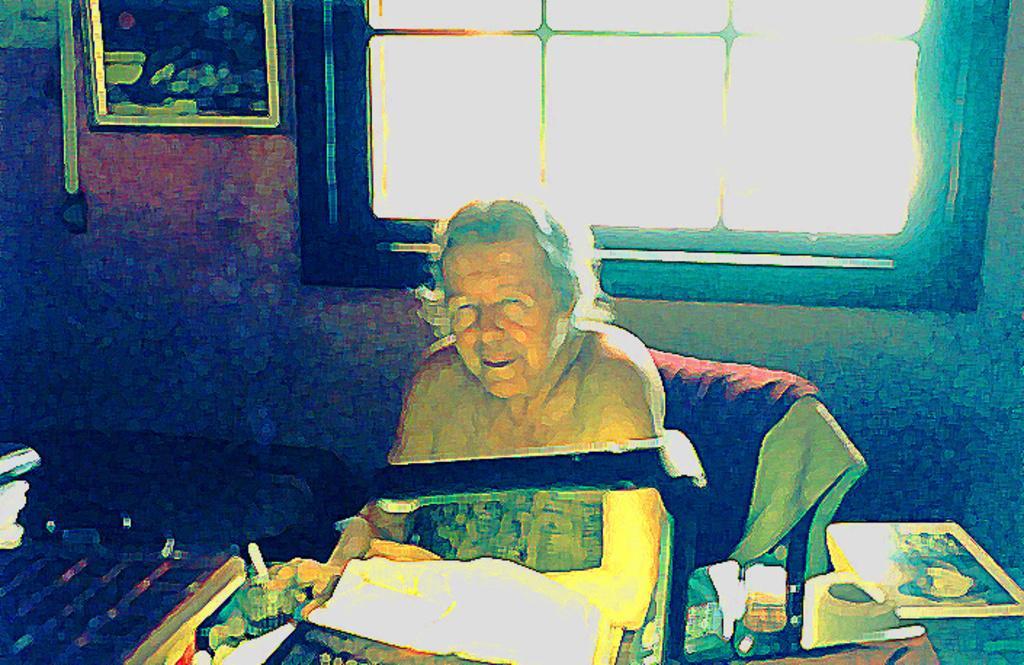Can you describe this image briefly? In this picture we can see a woman is seated on the chair, in front of her we can see a light and other things on the table, in the background we can see a frame on the wall. 